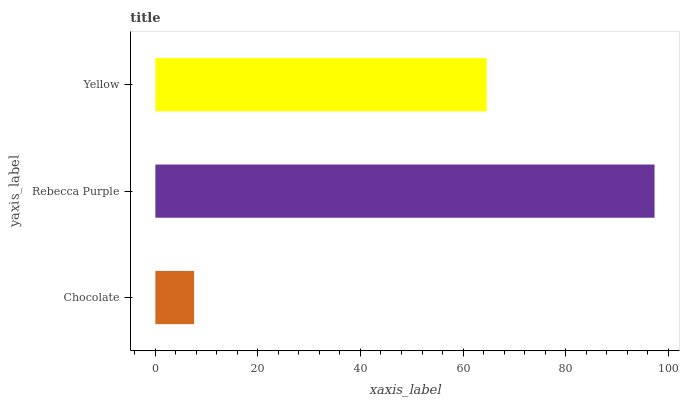Is Chocolate the minimum?
Answer yes or no. Yes. Is Rebecca Purple the maximum?
Answer yes or no. Yes. Is Yellow the minimum?
Answer yes or no. No. Is Yellow the maximum?
Answer yes or no. No. Is Rebecca Purple greater than Yellow?
Answer yes or no. Yes. Is Yellow less than Rebecca Purple?
Answer yes or no. Yes. Is Yellow greater than Rebecca Purple?
Answer yes or no. No. Is Rebecca Purple less than Yellow?
Answer yes or no. No. Is Yellow the high median?
Answer yes or no. Yes. Is Yellow the low median?
Answer yes or no. Yes. Is Chocolate the high median?
Answer yes or no. No. Is Rebecca Purple the low median?
Answer yes or no. No. 